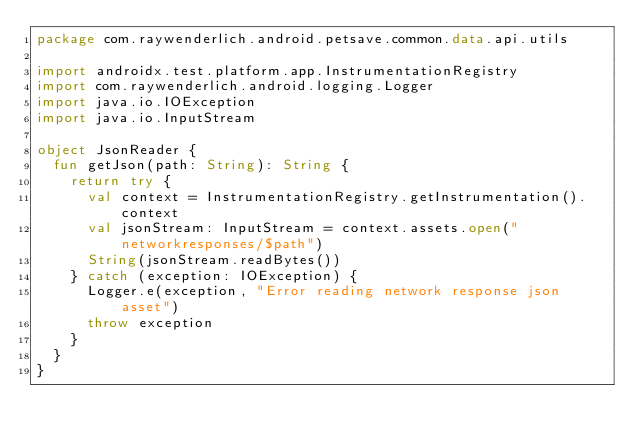Convert code to text. <code><loc_0><loc_0><loc_500><loc_500><_Kotlin_>package com.raywenderlich.android.petsave.common.data.api.utils

import androidx.test.platform.app.InstrumentationRegistry
import com.raywenderlich.android.logging.Logger
import java.io.IOException
import java.io.InputStream

object JsonReader {
  fun getJson(path: String): String {
    return try {
      val context = InstrumentationRegistry.getInstrumentation().context
      val jsonStream: InputStream = context.assets.open("networkresponses/$path")
      String(jsonStream.readBytes())
    } catch (exception: IOException) {
      Logger.e(exception, "Error reading network response json asset")
      throw exception
    }
  }
}</code> 